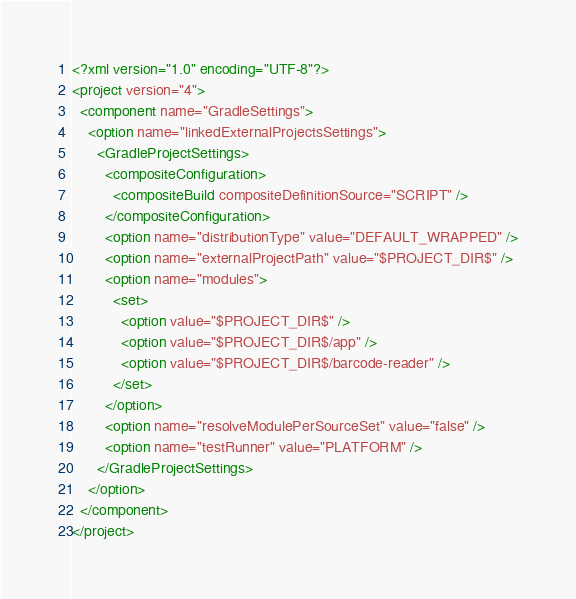<code> <loc_0><loc_0><loc_500><loc_500><_XML_><?xml version="1.0" encoding="UTF-8"?>
<project version="4">
  <component name="GradleSettings">
    <option name="linkedExternalProjectsSettings">
      <GradleProjectSettings>
        <compositeConfiguration>
          <compositeBuild compositeDefinitionSource="SCRIPT" />
        </compositeConfiguration>
        <option name="distributionType" value="DEFAULT_WRAPPED" />
        <option name="externalProjectPath" value="$PROJECT_DIR$" />
        <option name="modules">
          <set>
            <option value="$PROJECT_DIR$" />
            <option value="$PROJECT_DIR$/app" />
            <option value="$PROJECT_DIR$/barcode-reader" />
          </set>
        </option>
        <option name="resolveModulePerSourceSet" value="false" />
        <option name="testRunner" value="PLATFORM" />
      </GradleProjectSettings>
    </option>
  </component>
</project></code> 